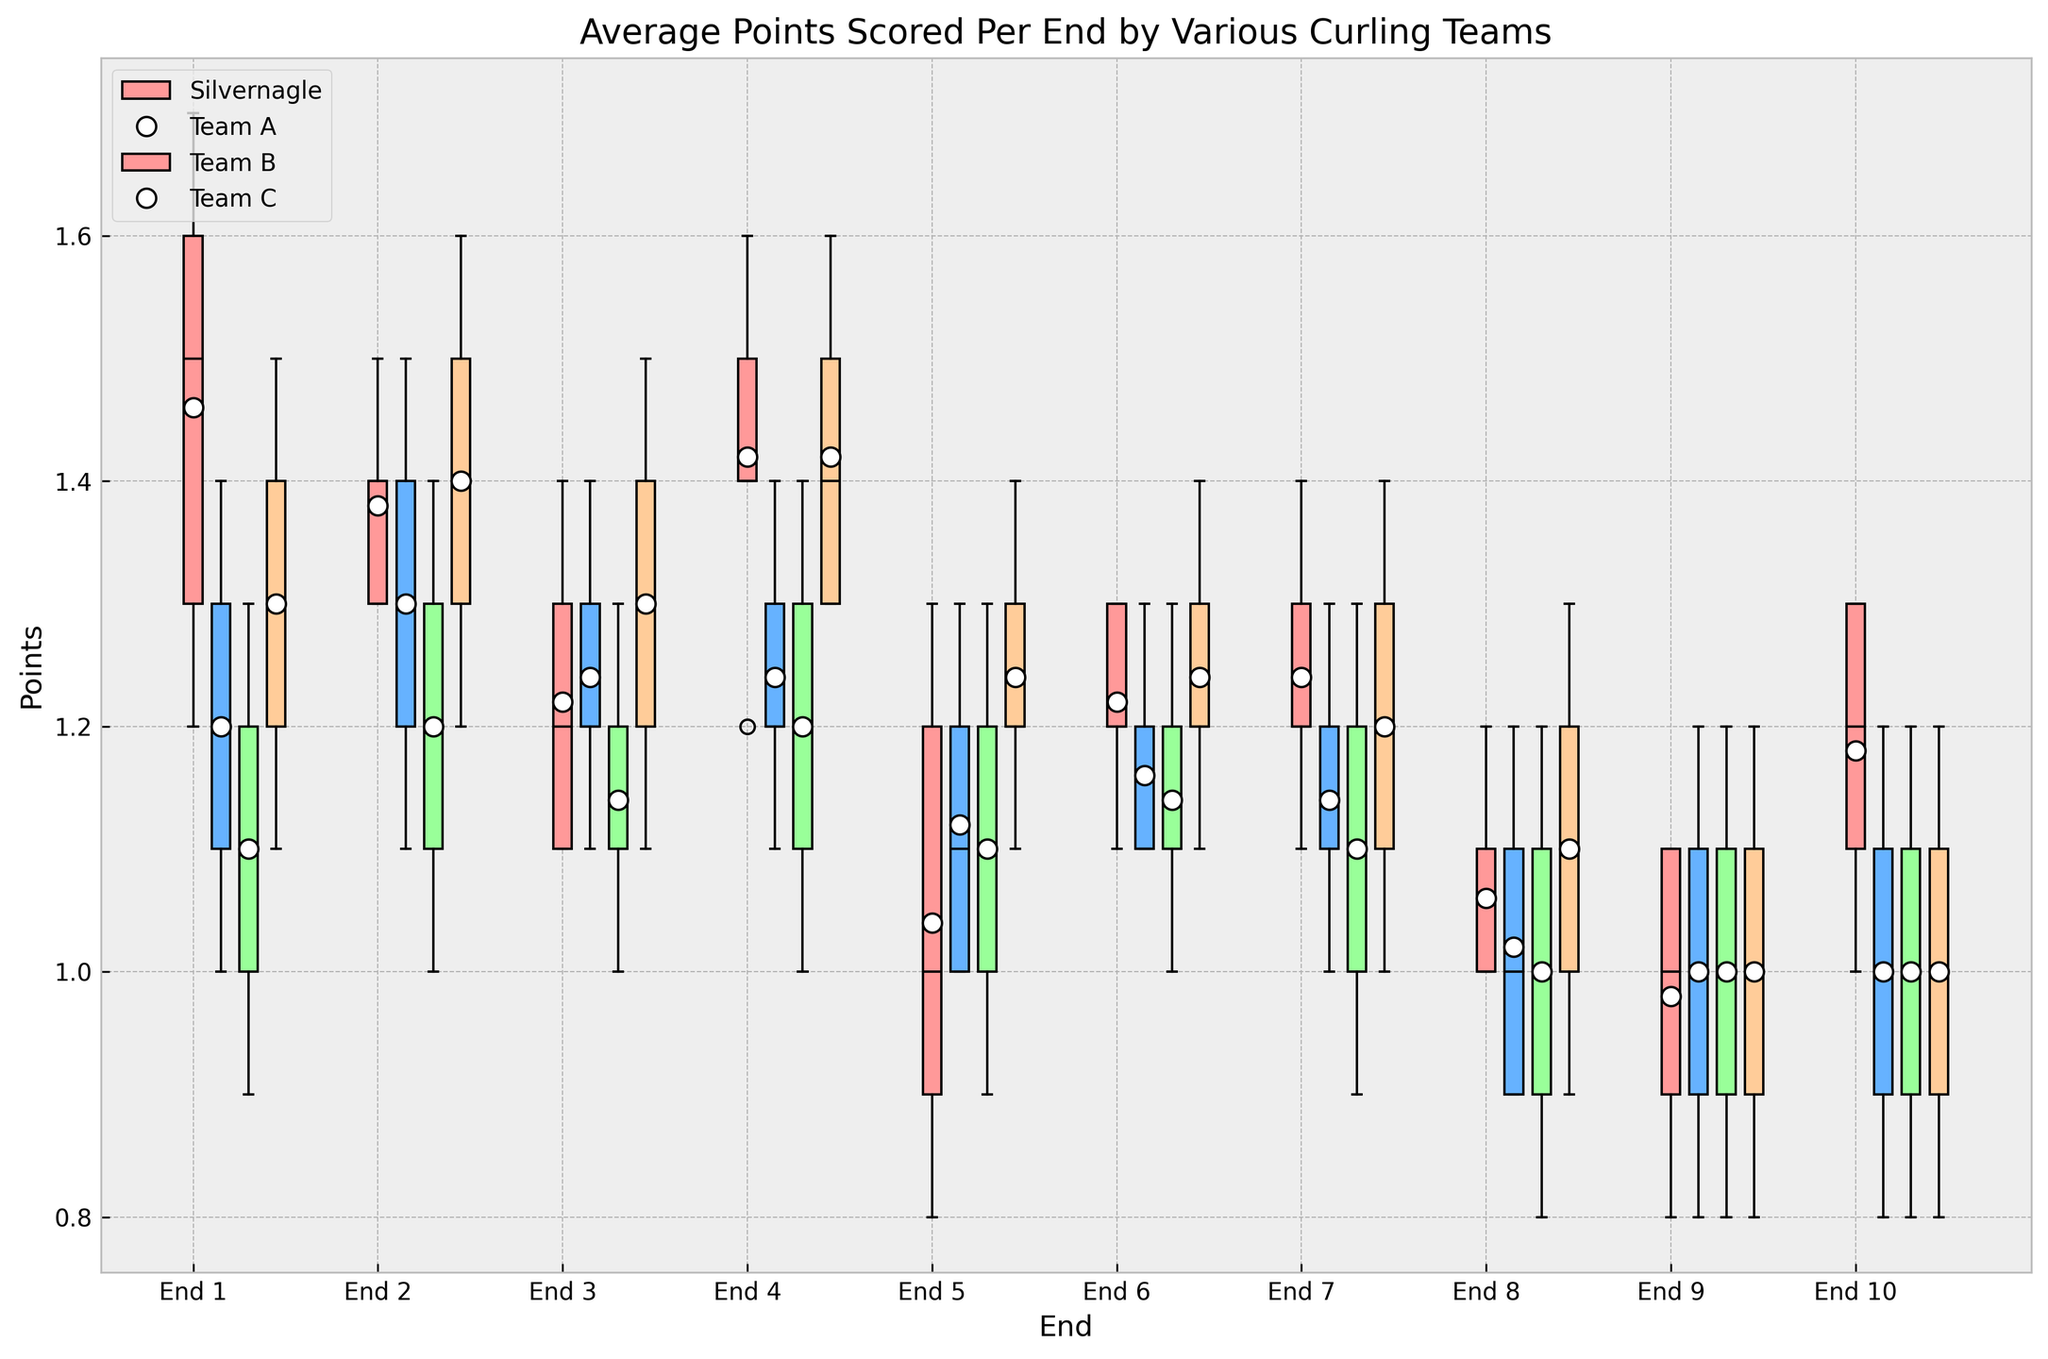Which team has the highest average points per End in 2020? By looking at the box plots for the year 2020, observe which team has the median (thick line within the box) placed the highest among all. Silvernagle's box plot in 2020 consistently shows higher medians compared to the other teams.
Answer: Silvernagle What is the trend in average points scored by Silvernagle’s team from 2016 to 2020? Observe the change in the median position (thick black line within the box) for Silvernagle's team over the years 2016 to 2020. Notice an upward trend, indicating that the median scores increase each subsequent year.
Answer: Increasing trend Which team had the lowest average points in 2016? Look at the 2016 box plots and compare the median values (thick black lines) for all teams. Team B has the lowest median point in 2016.
Answer: Team B Compare the spread of points in End 5 for all teams in 2020. Which team had the most variability? For End 5 in 2020, compare the lengths of the boxes representing each team. The box plot with the longest vertical range indicates the highest variability. In 2020, Team B has the longest box for End 5, showing the most variability.
Answer: Team B Were there any significant outliers in Silvernagle’s performance in 2019? Look for any data points outside the whiskers (line extensions beyond the box) in Silvernagle’s box plot for 2019. There are no points outside the whiskers, indicating no significant outliers.
Answer: No Which team had the closest median performance to Silvernagle in 2018? Compare the median line (thick black line within the boxes) of Silvernagle in 2018 with other teams' medians in the same year. Team C's median is closest to Silvernagle's median in 2018.
Answer: Team C What is the difference in the average points scored by Silvernagle in End 6 between 2016 and 2020? Check the median positions for End 6 in the years 2016 and 2020 for Silvernagle. Silvernagle's median in End 6 for 2016 is 1.1, and for 2020 it is 1.3. The difference is 1.3 - 1.1.
Answer: 0.2 Is there a visible trend in the performance of Team A from 2016 to 2020? Observe the movement of the median lines (thick black lines within the boxes) for Team A from 2016 to 2020. Notice an upward trend in the median, indicating improvement over these years.
Answer: Upward trend Which End generally had the lowest variability for all teams? Compare the lengths of the boxes across all Ends for all teams. The box with the smallest height indicates the lowest variability. End 10 generally has the smallest boxes, indicating the lowest variability.
Answer: End 10 